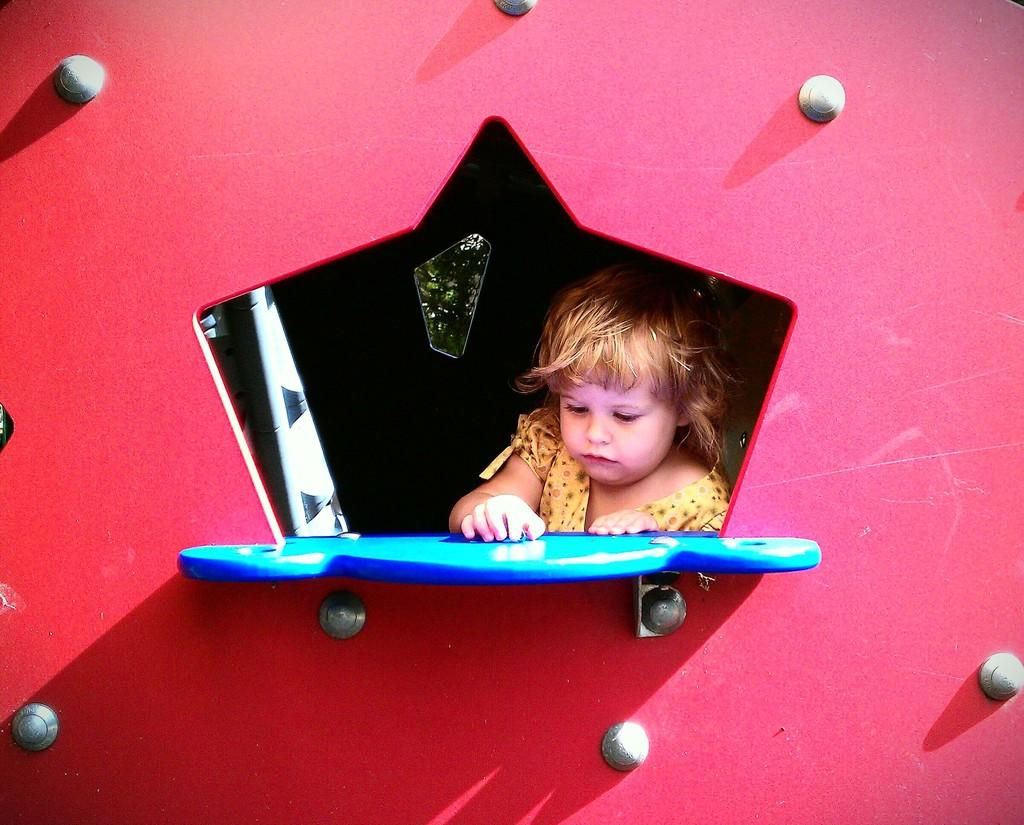What is the appearance of the wall in the image? The wall in the image is colorful. What can be seen attached to the wall? There are screws attached to the wall. Who or what is visible in the image? There is a baby visible in the image. What object is present in the image? A board is present in the image. What type of cord is being used by the baby to play in the image? There is no cord visible in the image, and the baby is not shown playing with any object. 